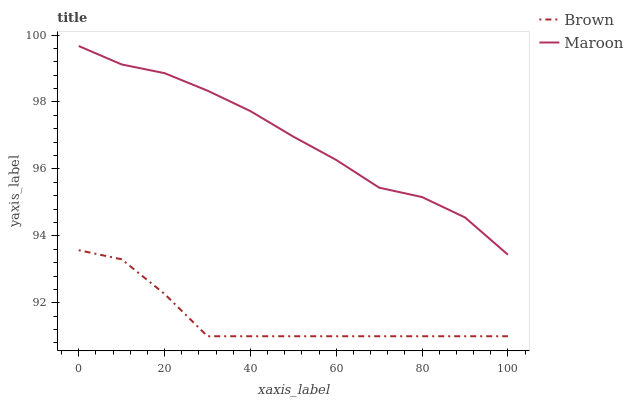Does Maroon have the minimum area under the curve?
Answer yes or no. No. Is Maroon the smoothest?
Answer yes or no. No. Does Maroon have the lowest value?
Answer yes or no. No. Is Brown less than Maroon?
Answer yes or no. Yes. Is Maroon greater than Brown?
Answer yes or no. Yes. Does Brown intersect Maroon?
Answer yes or no. No. 